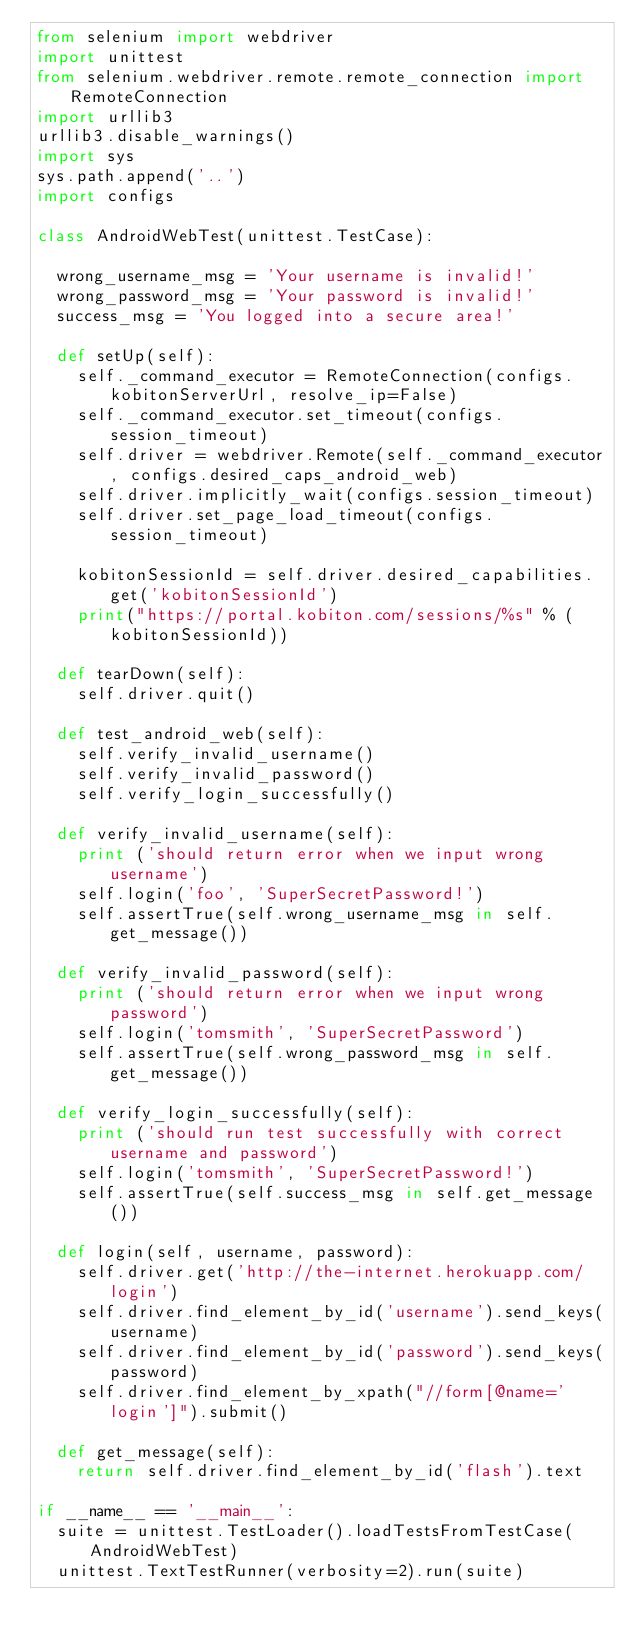<code> <loc_0><loc_0><loc_500><loc_500><_Python_>from selenium import webdriver
import unittest
from selenium.webdriver.remote.remote_connection import RemoteConnection
import urllib3
urllib3.disable_warnings()
import sys
sys.path.append('..')
import configs

class AndroidWebTest(unittest.TestCase):

  wrong_username_msg = 'Your username is invalid!'
  wrong_password_msg = 'Your password is invalid!'
  success_msg = 'You logged into a secure area!'

  def setUp(self):
    self._command_executor = RemoteConnection(configs.kobitonServerUrl, resolve_ip=False)
    self._command_executor.set_timeout(configs.session_timeout)
    self.driver = webdriver.Remote(self._command_executor, configs.desired_caps_android_web)
    self.driver.implicitly_wait(configs.session_timeout)
    self.driver.set_page_load_timeout(configs.session_timeout)

    kobitonSessionId = self.driver.desired_capabilities.get('kobitonSessionId')
    print("https://portal.kobiton.com/sessions/%s" % (kobitonSessionId))
    
  def tearDown(self):
    self.driver.quit()

  def test_android_web(self):
    self.verify_invalid_username()
    self.verify_invalid_password()
    self.verify_login_successfully()

  def verify_invalid_username(self):
    print ('should return error when we input wrong username')
    self.login('foo', 'SuperSecretPassword!')
    self.assertTrue(self.wrong_username_msg in self.get_message())

  def verify_invalid_password(self):
    print ('should return error when we input wrong password')
    self.login('tomsmith', 'SuperSecretPassword')
    self.assertTrue(self.wrong_password_msg in self.get_message())

  def verify_login_successfully(self):
    print ('should run test successfully with correct username and password')
    self.login('tomsmith', 'SuperSecretPassword!')
    self.assertTrue(self.success_msg in self.get_message())

  def login(self, username, password):
    self.driver.get('http://the-internet.herokuapp.com/login')
    self.driver.find_element_by_id('username').send_keys(username)
    self.driver.find_element_by_id('password').send_keys(password)
    self.driver.find_element_by_xpath("//form[@name='login']").submit()

  def get_message(self):
    return self.driver.find_element_by_id('flash').text

if __name__ == '__main__':
  suite = unittest.TestLoader().loadTestsFromTestCase(AndroidWebTest)
  unittest.TextTestRunner(verbosity=2).run(suite)</code> 